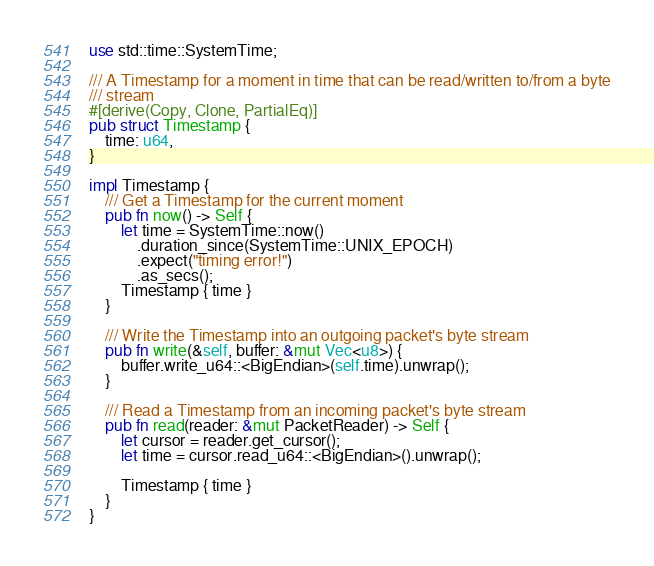Convert code to text. <code><loc_0><loc_0><loc_500><loc_500><_Rust_>use std::time::SystemTime;

/// A Timestamp for a moment in time that can be read/written to/from a byte
/// stream
#[derive(Copy, Clone, PartialEq)]
pub struct Timestamp {
    time: u64,
}

impl Timestamp {
    /// Get a Timestamp for the current moment
    pub fn now() -> Self {
        let time = SystemTime::now()
            .duration_since(SystemTime::UNIX_EPOCH)
            .expect("timing error!")
            .as_secs();
        Timestamp { time }
    }

    /// Write the Timestamp into an outgoing packet's byte stream
    pub fn write(&self, buffer: &mut Vec<u8>) {
        buffer.write_u64::<BigEndian>(self.time).unwrap();
    }

    /// Read a Timestamp from an incoming packet's byte stream
    pub fn read(reader: &mut PacketReader) -> Self {
        let cursor = reader.get_cursor();
        let time = cursor.read_u64::<BigEndian>().unwrap();

        Timestamp { time }
    }
}
</code> 